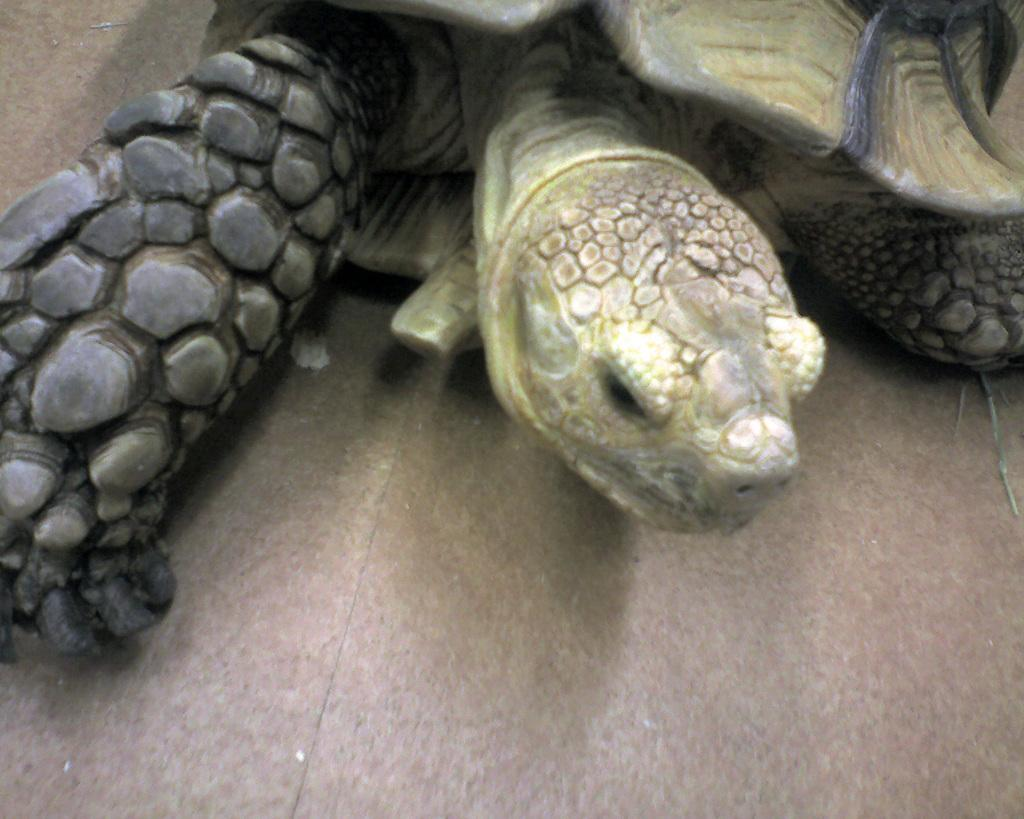What type of animal is present in the image? There is a reptile in the image. What type of parenting advice does the reptile give in the image? There is no indication in the image that the reptile is giving parenting advice, as the image only shows the reptile itself and does not depict any interaction or context. 